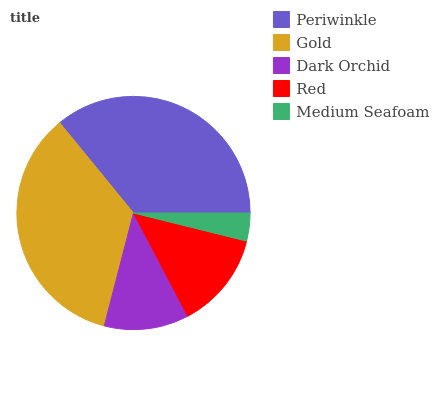Is Medium Seafoam the minimum?
Answer yes or no. Yes. Is Periwinkle the maximum?
Answer yes or no. Yes. Is Gold the minimum?
Answer yes or no. No. Is Gold the maximum?
Answer yes or no. No. Is Periwinkle greater than Gold?
Answer yes or no. Yes. Is Gold less than Periwinkle?
Answer yes or no. Yes. Is Gold greater than Periwinkle?
Answer yes or no. No. Is Periwinkle less than Gold?
Answer yes or no. No. Is Red the high median?
Answer yes or no. Yes. Is Red the low median?
Answer yes or no. Yes. Is Dark Orchid the high median?
Answer yes or no. No. Is Dark Orchid the low median?
Answer yes or no. No. 